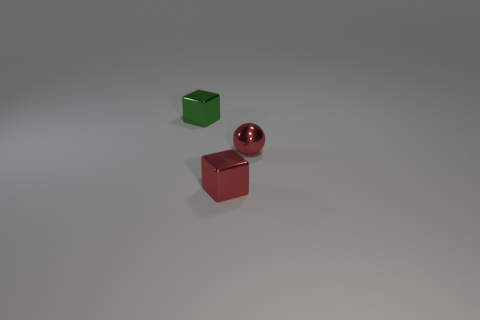There is a small object that is both to the left of the small shiny ball and to the right of the green shiny cube; what is its shape?
Your response must be concise. Cube. How many small red objects have the same shape as the green shiny thing?
Offer a very short reply. 1. How many big green spheres are there?
Your answer should be very brief. 0. There is a shiny object that is both left of the ball and to the right of the green metallic thing; how big is it?
Ensure brevity in your answer.  Small. What is the shape of the red metallic thing that is the same size as the sphere?
Make the answer very short. Cube. Are there any tiny shiny cubes that are on the right side of the green block behind the small red sphere?
Ensure brevity in your answer.  Yes. There is another tiny object that is the same shape as the tiny green metal thing; what color is it?
Make the answer very short. Red. Does the metal thing to the left of the tiny red cube have the same color as the ball?
Give a very brief answer. No. How many objects are either small cubes that are in front of the small green cube or tiny green blocks?
Offer a terse response. 2. There is a small green cube to the left of the small red metallic object right of the metallic cube that is right of the green metallic thing; what is it made of?
Your answer should be very brief. Metal. 